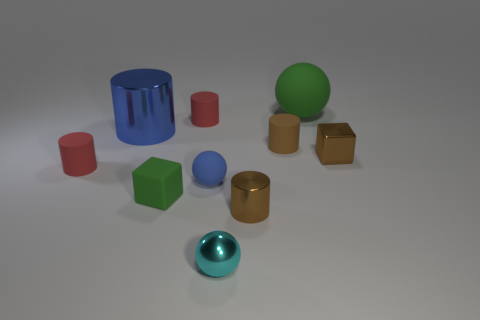What is the size of the brown cylinder that is the same material as the tiny green cube? The brown cylinder appears to be medium-sized compared to other objects in the image, with a similar matte finish to the tiny green cube, suggesting they are made of the same material. 